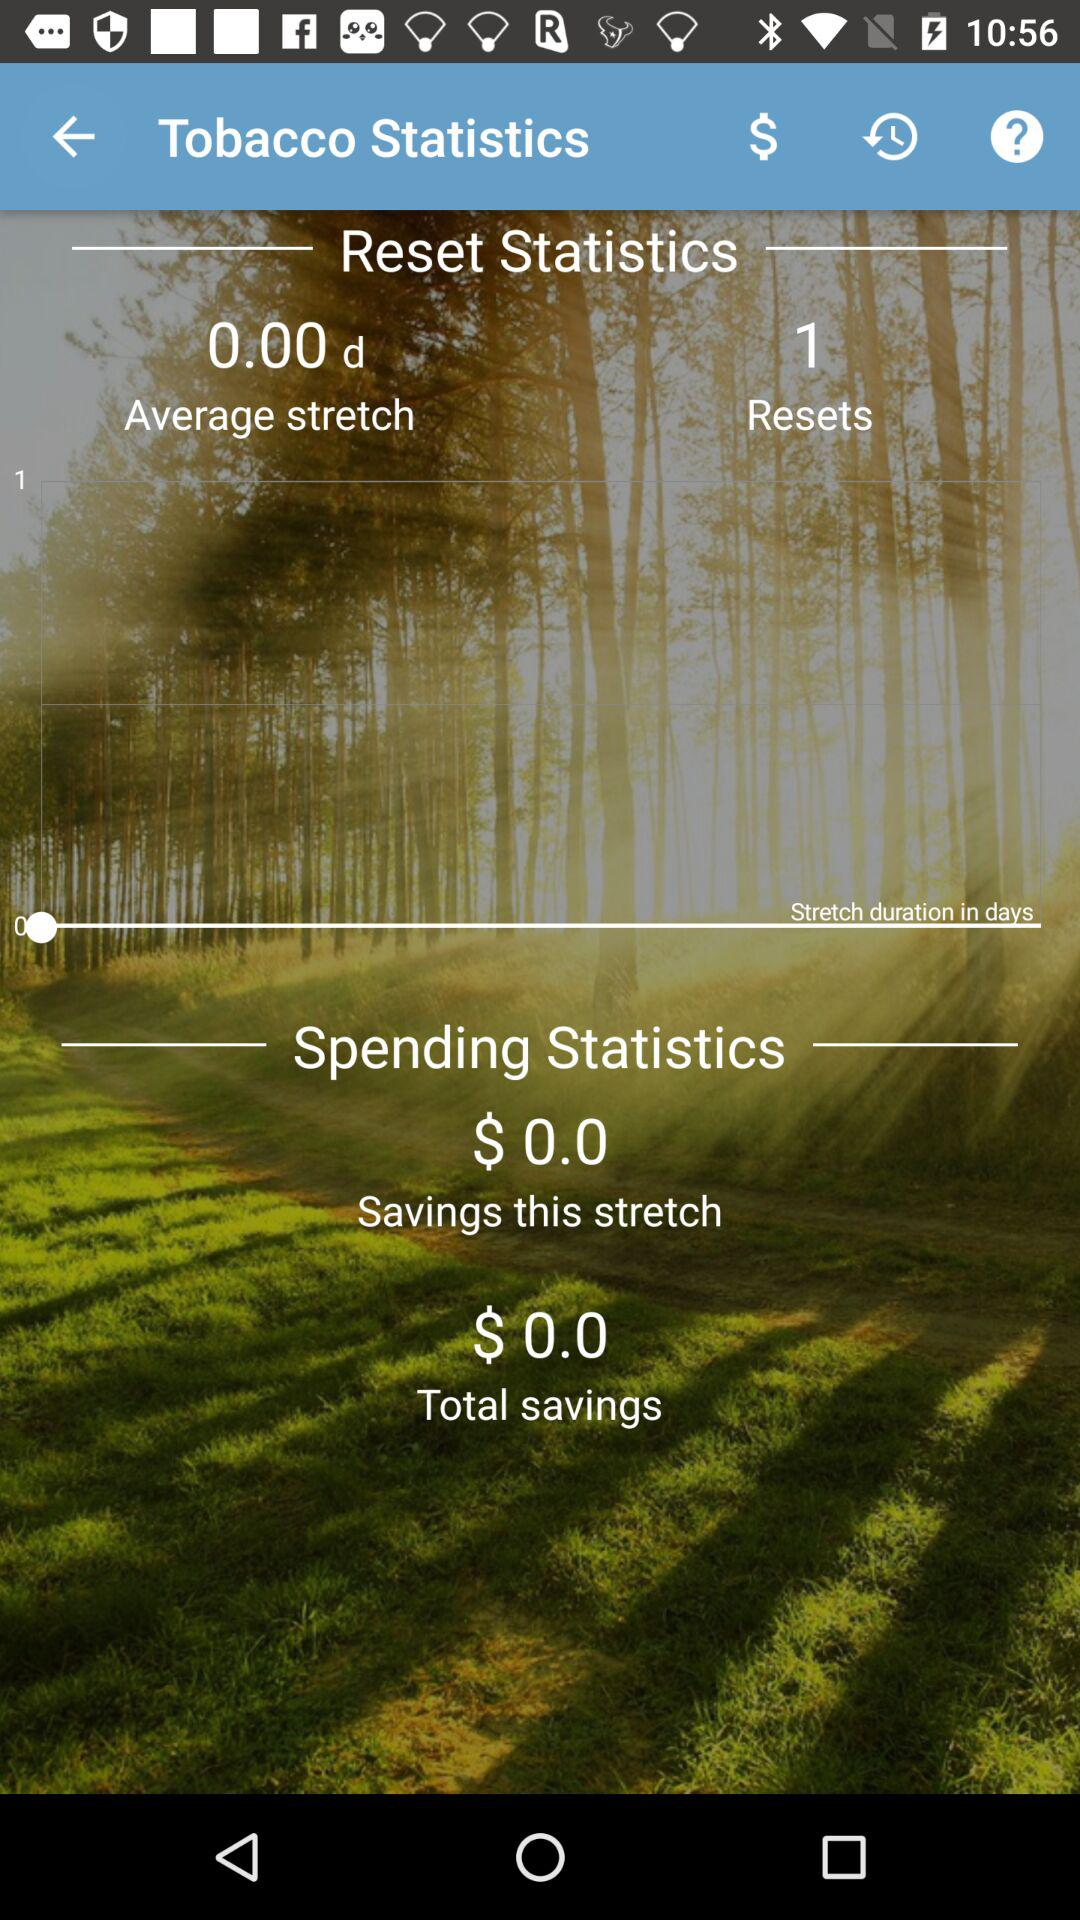What is the total saving? The total saving is $0.0. 